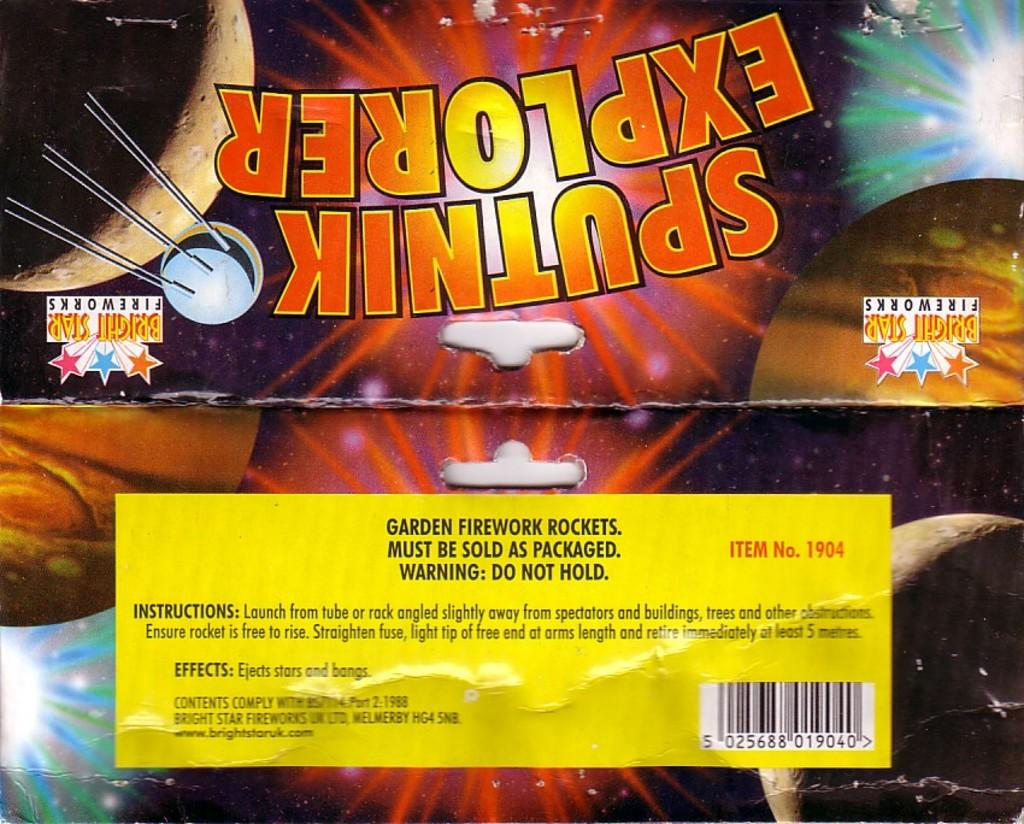<image>
Relay a brief, clear account of the picture shown. A package of firewords reading Sputnink explorer with images of the planets. 